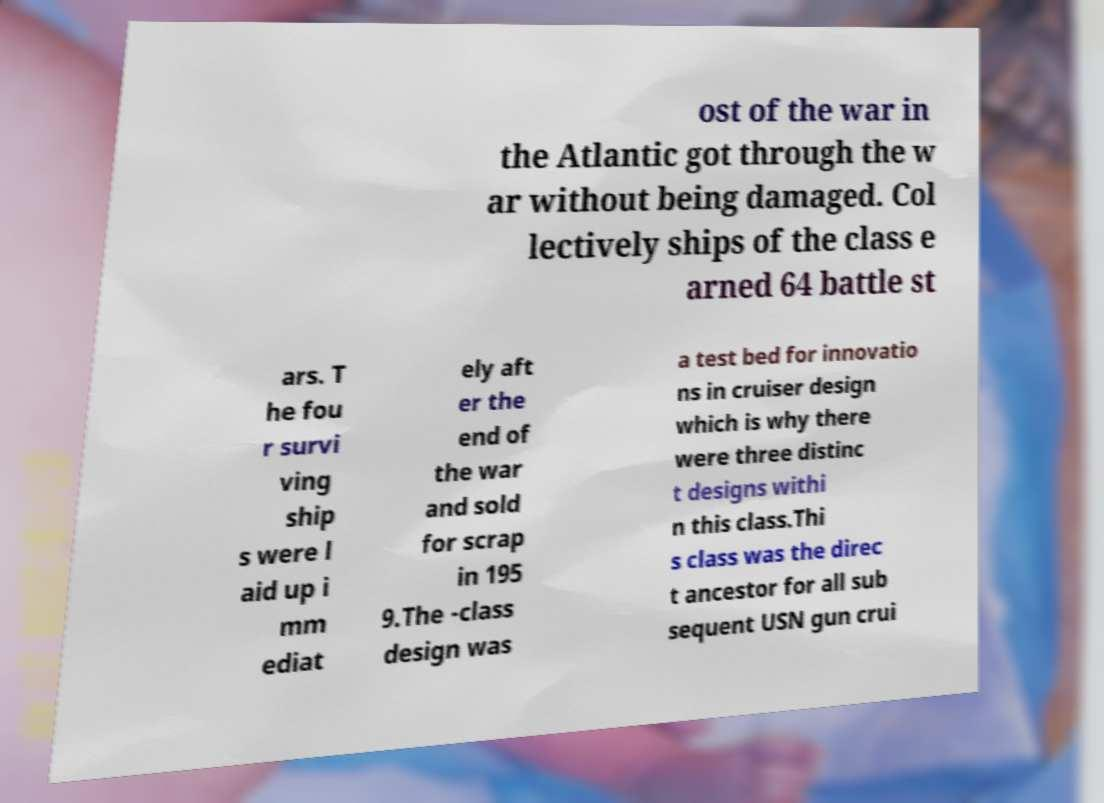There's text embedded in this image that I need extracted. Can you transcribe it verbatim? ost of the war in the Atlantic got through the w ar without being damaged. Col lectively ships of the class e arned 64 battle st ars. T he fou r survi ving ship s were l aid up i mm ediat ely aft er the end of the war and sold for scrap in 195 9.The -class design was a test bed for innovatio ns in cruiser design which is why there were three distinc t designs withi n this class.Thi s class was the direc t ancestor for all sub sequent USN gun crui 